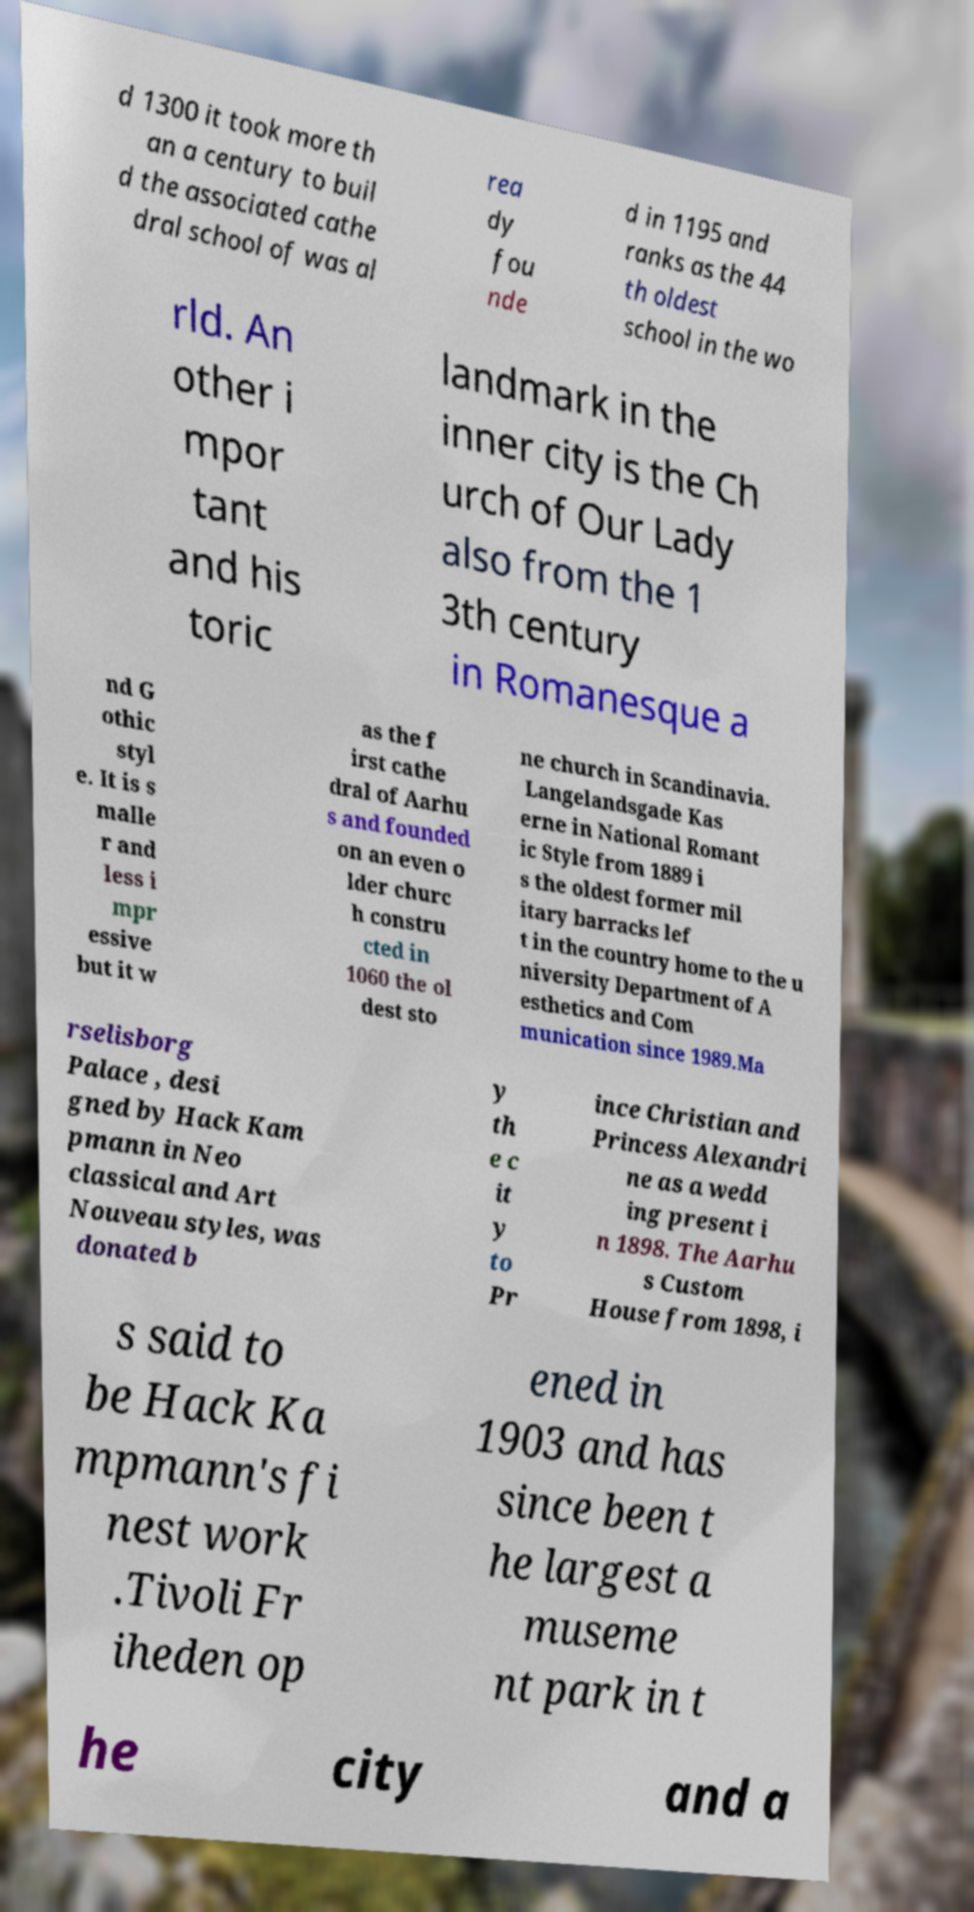Can you accurately transcribe the text from the provided image for me? d 1300 it took more th an a century to buil d the associated cathe dral school of was al rea dy fou nde d in 1195 and ranks as the 44 th oldest school in the wo rld. An other i mpor tant and his toric landmark in the inner city is the Ch urch of Our Lady also from the 1 3th century in Romanesque a nd G othic styl e. It is s malle r and less i mpr essive but it w as the f irst cathe dral of Aarhu s and founded on an even o lder churc h constru cted in 1060 the ol dest sto ne church in Scandinavia. Langelandsgade Kas erne in National Romant ic Style from 1889 i s the oldest former mil itary barracks lef t in the country home to the u niversity Department of A esthetics and Com munication since 1989.Ma rselisborg Palace , desi gned by Hack Kam pmann in Neo classical and Art Nouveau styles, was donated b y th e c it y to Pr ince Christian and Princess Alexandri ne as a wedd ing present i n 1898. The Aarhu s Custom House from 1898, i s said to be Hack Ka mpmann's fi nest work .Tivoli Fr iheden op ened in 1903 and has since been t he largest a museme nt park in t he city and a 